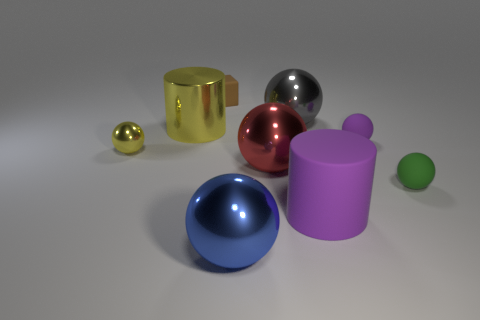Do the cylinder that is left of the purple rubber cylinder and the cube have the same color?
Make the answer very short. No. What number of objects are tiny yellow rubber cylinders or things in front of the big red thing?
Provide a succinct answer. 3. There is a green object that is on the right side of the red metal object; is it the same shape as the large metal thing that is left of the tiny brown matte block?
Ensure brevity in your answer.  No. Is there any other thing that is the same color as the rubber block?
Give a very brief answer. No. There is a big thing that is the same material as the tiny green object; what shape is it?
Provide a short and direct response. Cylinder. There is a small object that is both right of the large yellow metal cylinder and to the left of the tiny purple sphere; what is it made of?
Offer a very short reply. Rubber. Is there any other thing that is the same size as the gray sphere?
Your answer should be very brief. Yes. Do the matte block and the big matte cylinder have the same color?
Your answer should be very brief. No. What is the shape of the object that is the same color as the small shiny ball?
Offer a very short reply. Cylinder. How many blue shiny things are the same shape as the gray thing?
Your answer should be very brief. 1. 